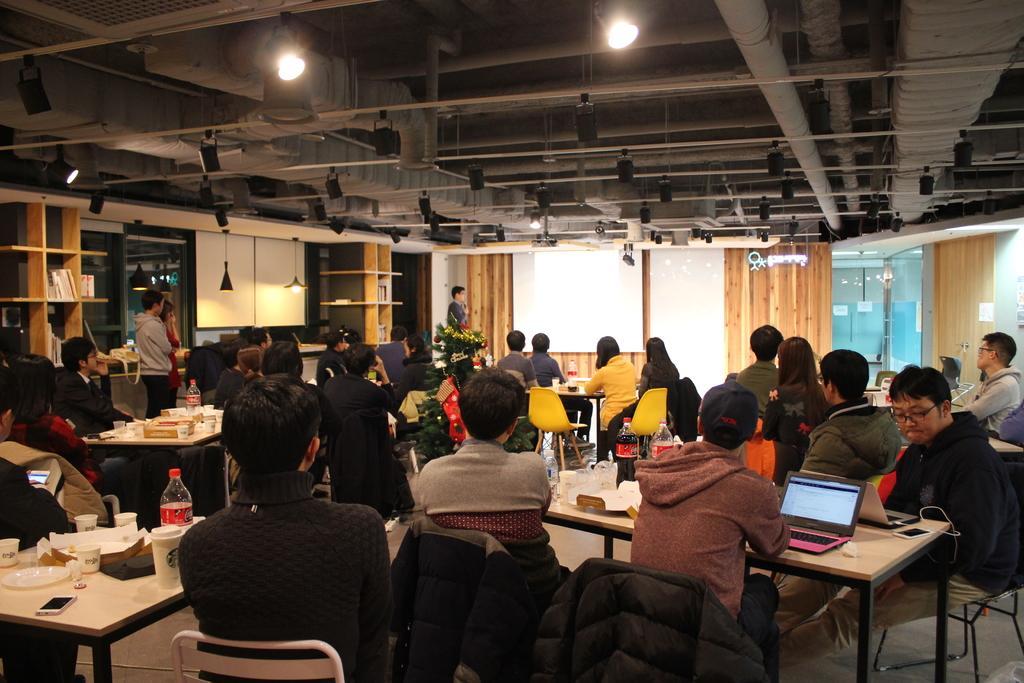Could you give a brief overview of what you see in this image? People are sitting in groups at tables and listening to a man whose is giving a presentation at a screen. 